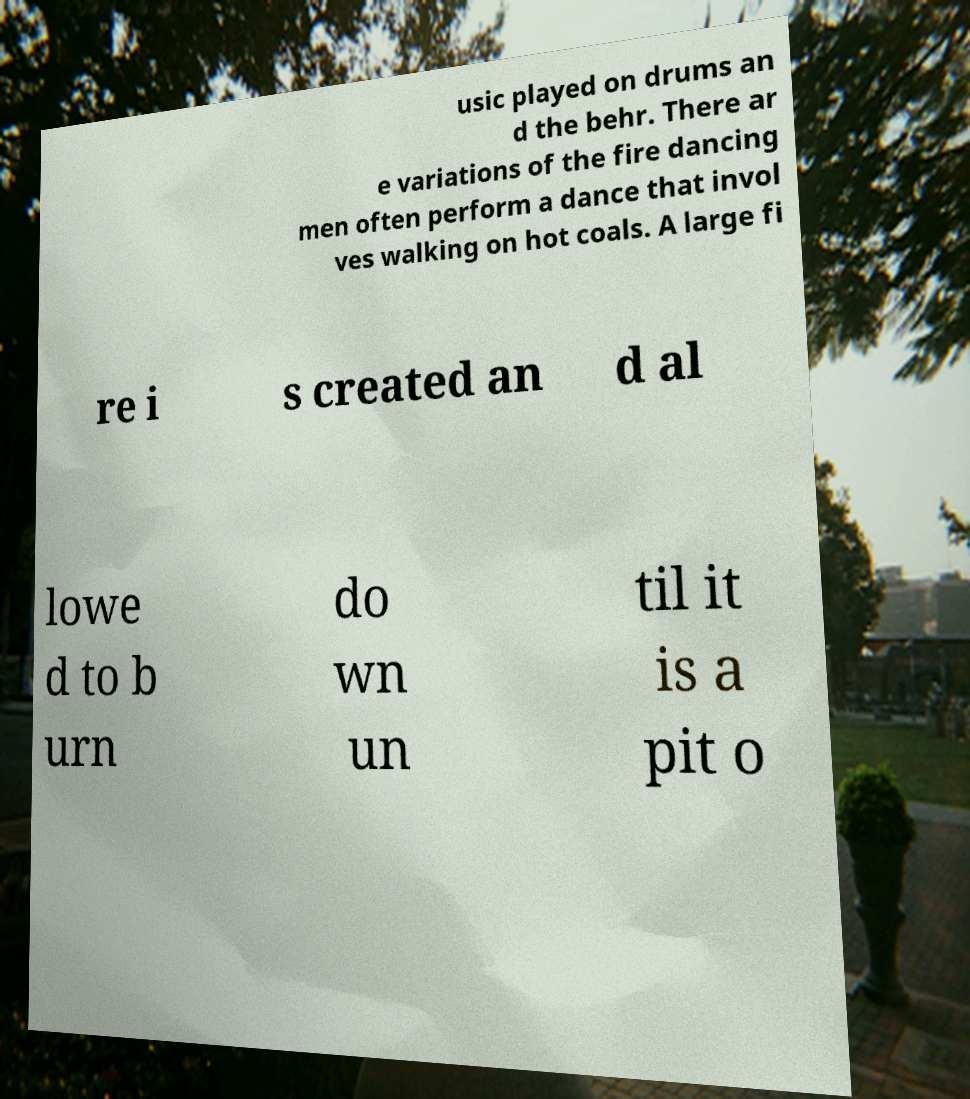There's text embedded in this image that I need extracted. Can you transcribe it verbatim? usic played on drums an d the behr. There ar e variations of the fire dancing men often perform a dance that invol ves walking on hot coals. A large fi re i s created an d al lowe d to b urn do wn un til it is a pit o 